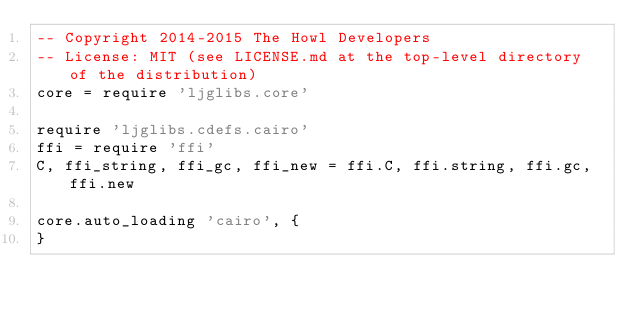Convert code to text. <code><loc_0><loc_0><loc_500><loc_500><_MoonScript_>-- Copyright 2014-2015 The Howl Developers
-- License: MIT (see LICENSE.md at the top-level directory of the distribution)
core = require 'ljglibs.core'

require 'ljglibs.cdefs.cairo'
ffi = require 'ffi'
C, ffi_string, ffi_gc, ffi_new = ffi.C, ffi.string, ffi.gc, ffi.new

core.auto_loading 'cairo', {
}
</code> 